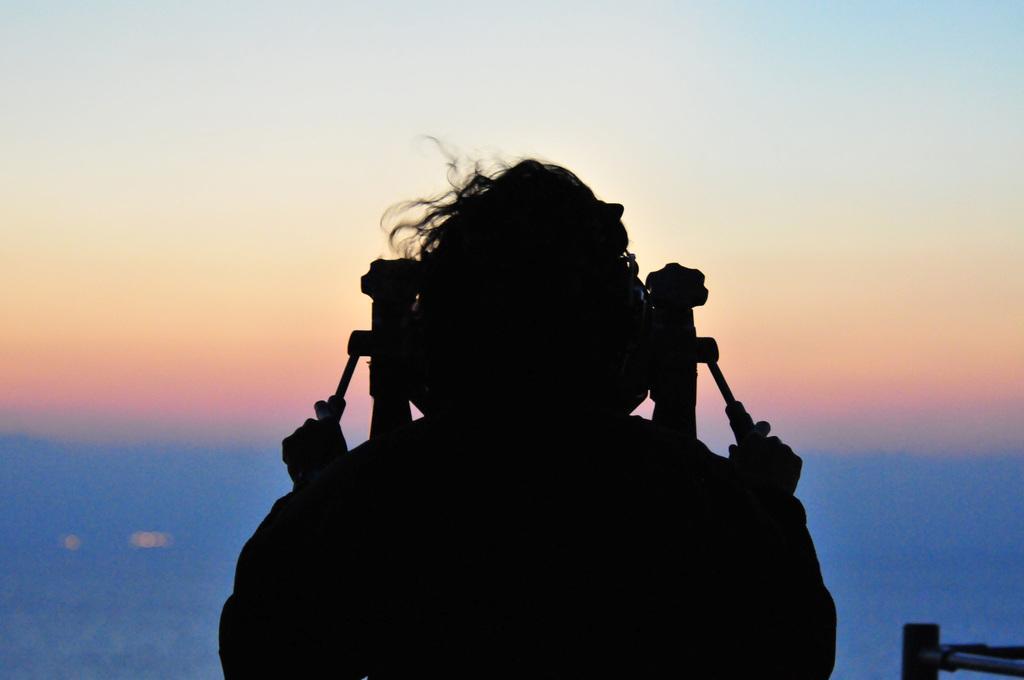In one or two sentences, can you explain what this image depicts? In this image we can see a person holding an object with his hand. On the right side we can see a metal stand. On the backside we can see a water body and the sky which looks cloudy. 